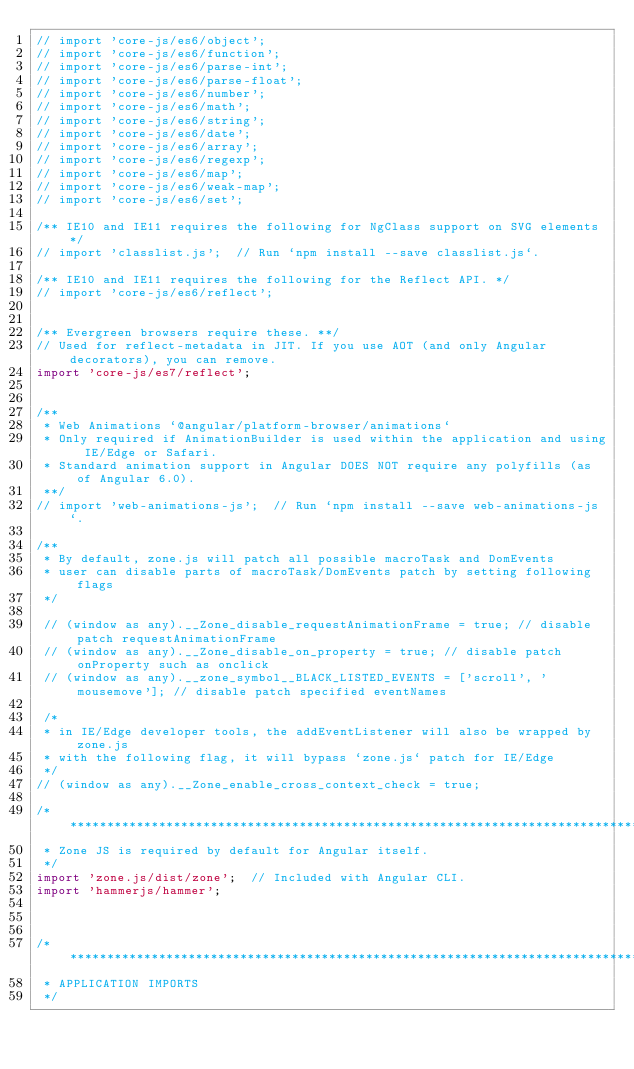Convert code to text. <code><loc_0><loc_0><loc_500><loc_500><_TypeScript_>// import 'core-js/es6/object';
// import 'core-js/es6/function';
// import 'core-js/es6/parse-int';
// import 'core-js/es6/parse-float';
// import 'core-js/es6/number';
// import 'core-js/es6/math';
// import 'core-js/es6/string';
// import 'core-js/es6/date';
// import 'core-js/es6/array';
// import 'core-js/es6/regexp';
// import 'core-js/es6/map';
// import 'core-js/es6/weak-map';
// import 'core-js/es6/set';

/** IE10 and IE11 requires the following for NgClass support on SVG elements */
// import 'classlist.js';  // Run `npm install --save classlist.js`.

/** IE10 and IE11 requires the following for the Reflect API. */
// import 'core-js/es6/reflect';


/** Evergreen browsers require these. **/
// Used for reflect-metadata in JIT. If you use AOT (and only Angular decorators), you can remove.
import 'core-js/es7/reflect';


/**
 * Web Animations `@angular/platform-browser/animations`
 * Only required if AnimationBuilder is used within the application and using IE/Edge or Safari.
 * Standard animation support in Angular DOES NOT require any polyfills (as of Angular 6.0).
 **/
// import 'web-animations-js';  // Run `npm install --save web-animations-js`.

/**
 * By default, zone.js will patch all possible macroTask and DomEvents
 * user can disable parts of macroTask/DomEvents patch by setting following flags
 */

 // (window as any).__Zone_disable_requestAnimationFrame = true; // disable patch requestAnimationFrame
 // (window as any).__Zone_disable_on_property = true; // disable patch onProperty such as onclick
 // (window as any).__zone_symbol__BLACK_LISTED_EVENTS = ['scroll', 'mousemove']; // disable patch specified eventNames

 /*
 * in IE/Edge developer tools, the addEventListener will also be wrapped by zone.js
 * with the following flag, it will bypass `zone.js` patch for IE/Edge
 */
// (window as any).__Zone_enable_cross_context_check = true;

/***************************************************************************************************
 * Zone JS is required by default for Angular itself.
 */
import 'zone.js/dist/zone';  // Included with Angular CLI.
import 'hammerjs/hammer';



/***************************************************************************************************
 * APPLICATION IMPORTS
 */
</code> 